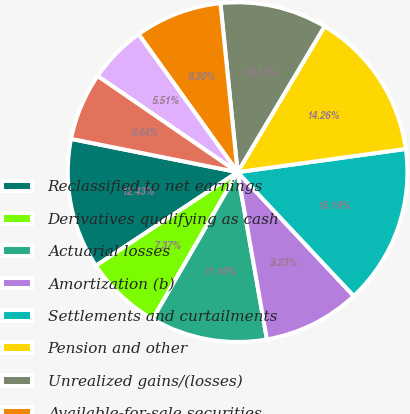Convert chart to OTSL. <chart><loc_0><loc_0><loc_500><loc_500><pie_chart><fcel>Reclassified to net earnings<fcel>Derivatives qualifying as cash<fcel>Actuarial losses<fcel>Amortization (b)<fcel>Settlements and curtailments<fcel>Pension and other<fcel>Unrealized gains/(losses)<fcel>Available-for-sale securities<fcel>Foreign currency translation<fcel>Total Other Comprehensive<nl><fcel>12.43%<fcel>7.37%<fcel>11.1%<fcel>9.23%<fcel>15.19%<fcel>14.26%<fcel>10.17%<fcel>8.3%<fcel>5.51%<fcel>6.44%<nl></chart> 